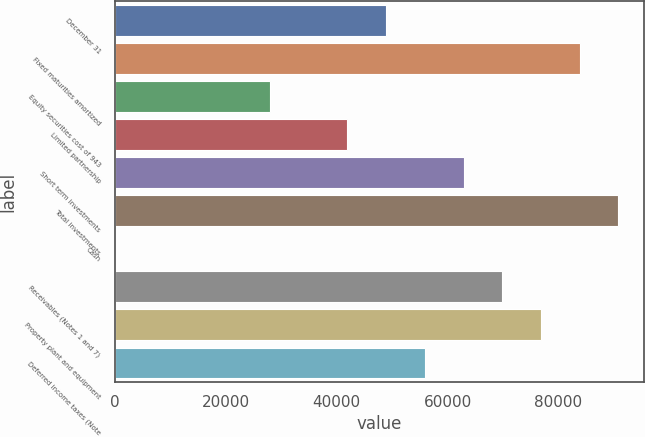Convert chart. <chart><loc_0><loc_0><loc_500><loc_500><bar_chart><fcel>December 31<fcel>Fixed maturities amortized<fcel>Equity securities cost of 943<fcel>Limited partnership<fcel>Short term investments<fcel>Total investments<fcel>Cash<fcel>Receivables (Notes 1 and 7)<fcel>Property plant and equipment<fcel>Deferred income taxes (Note<nl><fcel>48948.3<fcel>83817.8<fcel>28026.6<fcel>41974.4<fcel>62896.1<fcel>90791.7<fcel>131<fcel>69870<fcel>76843.9<fcel>55922.2<nl></chart> 